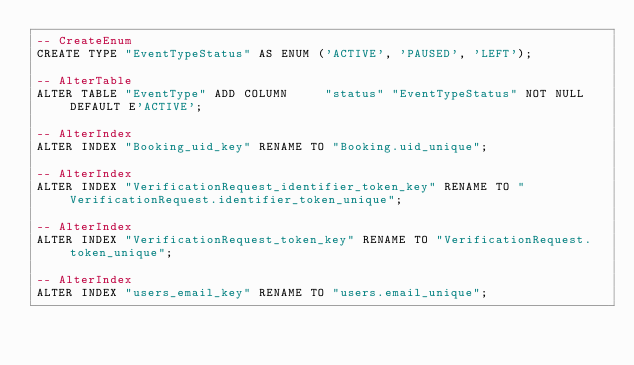Convert code to text. <code><loc_0><loc_0><loc_500><loc_500><_SQL_>-- CreateEnum
CREATE TYPE "EventTypeStatus" AS ENUM ('ACTIVE', 'PAUSED', 'LEFT');

-- AlterTable
ALTER TABLE "EventType" ADD COLUMN     "status" "EventTypeStatus" NOT NULL DEFAULT E'ACTIVE';

-- AlterIndex
ALTER INDEX "Booking_uid_key" RENAME TO "Booking.uid_unique";

-- AlterIndex
ALTER INDEX "VerificationRequest_identifier_token_key" RENAME TO "VerificationRequest.identifier_token_unique";

-- AlterIndex
ALTER INDEX "VerificationRequest_token_key" RENAME TO "VerificationRequest.token_unique";

-- AlterIndex
ALTER INDEX "users_email_key" RENAME TO "users.email_unique";
</code> 